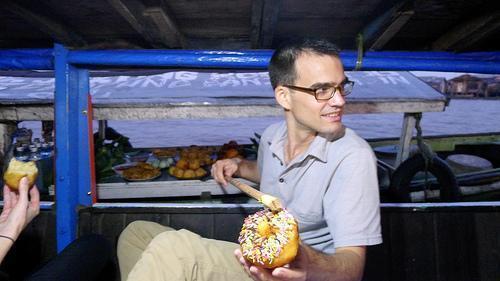How many donuts are in the man's hand?
Give a very brief answer. 1. How many arms does the man have?
Give a very brief answer. 2. How many glasses does the man have?
Give a very brief answer. 1. 